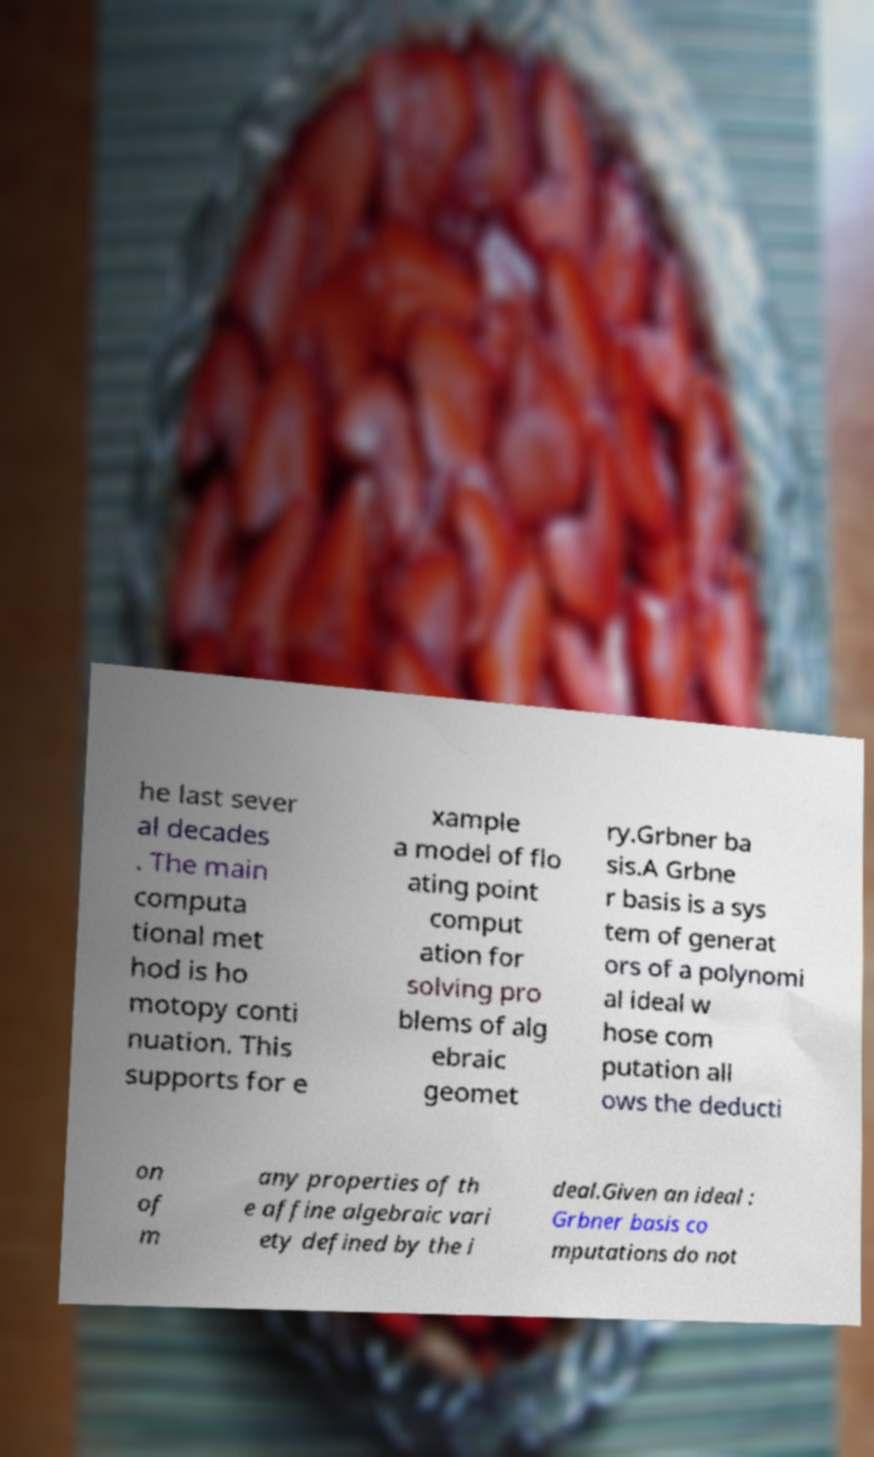What messages or text are displayed in this image? I need them in a readable, typed format. he last sever al decades . The main computa tional met hod is ho motopy conti nuation. This supports for e xample a model of flo ating point comput ation for solving pro blems of alg ebraic geomet ry.Grbner ba sis.A Grbne r basis is a sys tem of generat ors of a polynomi al ideal w hose com putation all ows the deducti on of m any properties of th e affine algebraic vari ety defined by the i deal.Given an ideal : Grbner basis co mputations do not 